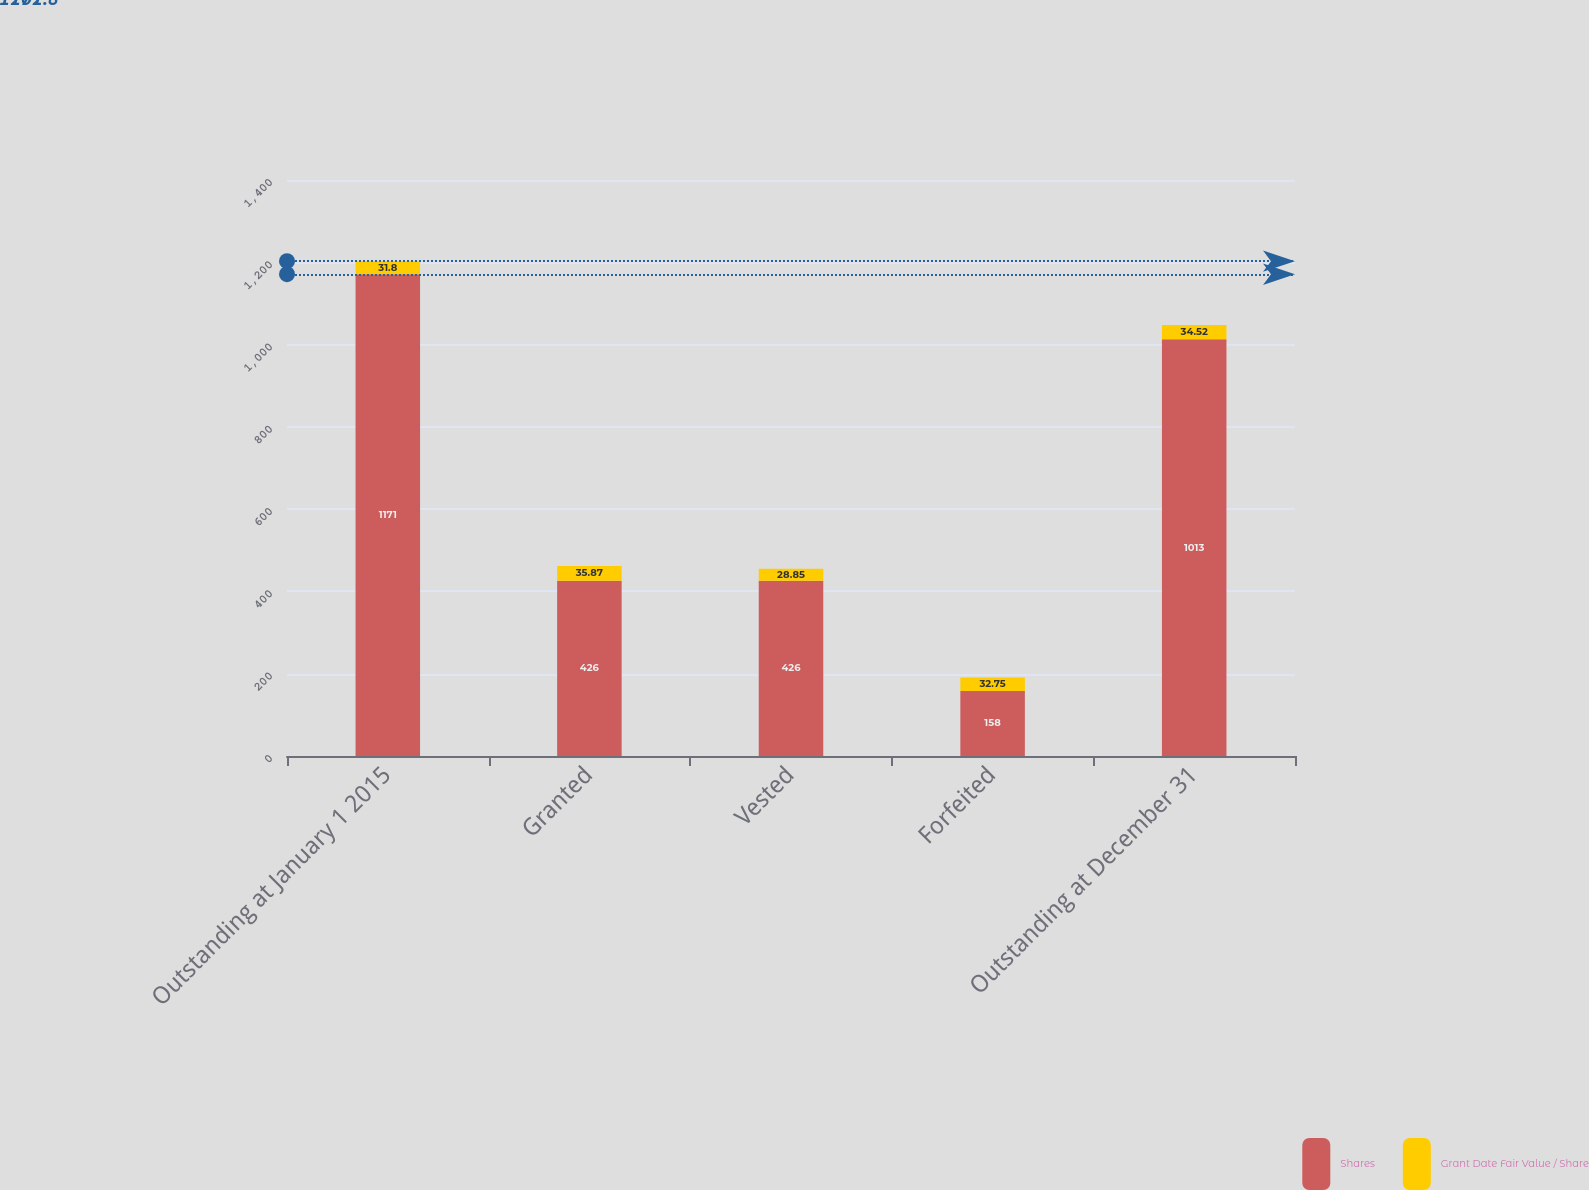Convert chart to OTSL. <chart><loc_0><loc_0><loc_500><loc_500><stacked_bar_chart><ecel><fcel>Outstanding at January 1 2015<fcel>Granted<fcel>Vested<fcel>Forfeited<fcel>Outstanding at December 31<nl><fcel>Shares<fcel>1171<fcel>426<fcel>426<fcel>158<fcel>1013<nl><fcel>Grant Date Fair Value / Share<fcel>31.8<fcel>35.87<fcel>28.85<fcel>32.75<fcel>34.52<nl></chart> 